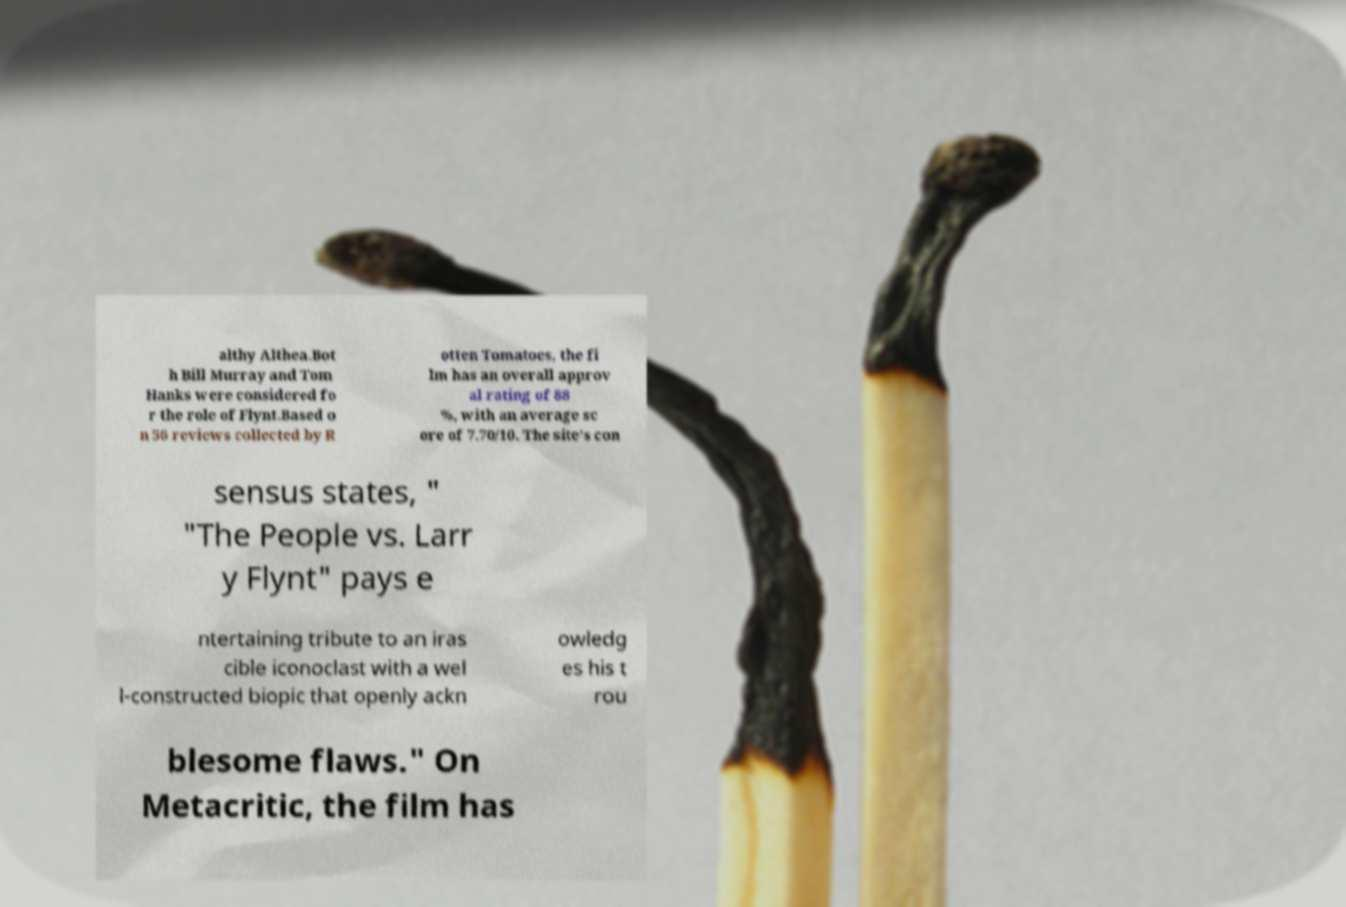For documentation purposes, I need the text within this image transcribed. Could you provide that? althy Althea.Bot h Bill Murray and Tom Hanks were considered fo r the role of Flynt.Based o n 56 reviews collected by R otten Tomatoes, the fi lm has an overall approv al rating of 88 %, with an average sc ore of 7.70/10. The site's con sensus states, " "The People vs. Larr y Flynt" pays e ntertaining tribute to an iras cible iconoclast with a wel l-constructed biopic that openly ackn owledg es his t rou blesome flaws." On Metacritic, the film has 